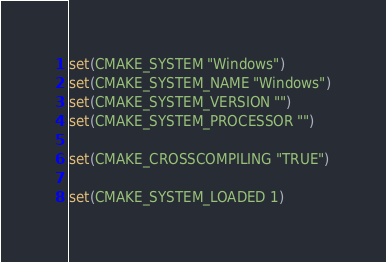Convert code to text. <code><loc_0><loc_0><loc_500><loc_500><_CMake_>
set(CMAKE_SYSTEM "Windows")
set(CMAKE_SYSTEM_NAME "Windows")
set(CMAKE_SYSTEM_VERSION "")
set(CMAKE_SYSTEM_PROCESSOR "")

set(CMAKE_CROSSCOMPILING "TRUE")

set(CMAKE_SYSTEM_LOADED 1)
</code> 